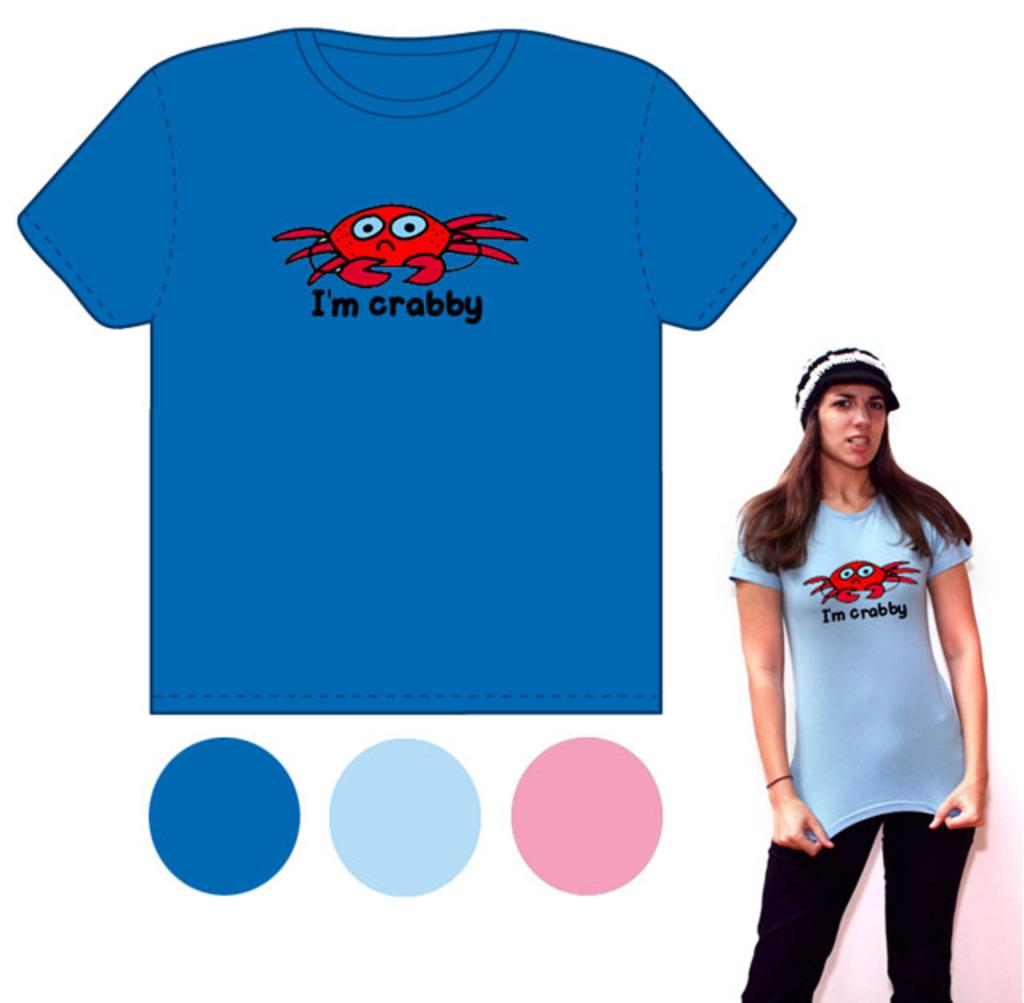<image>
Offer a succinct explanation of the picture presented. An ad for a tee shirt with a crab on the front and underneath it says I'm crabby. 